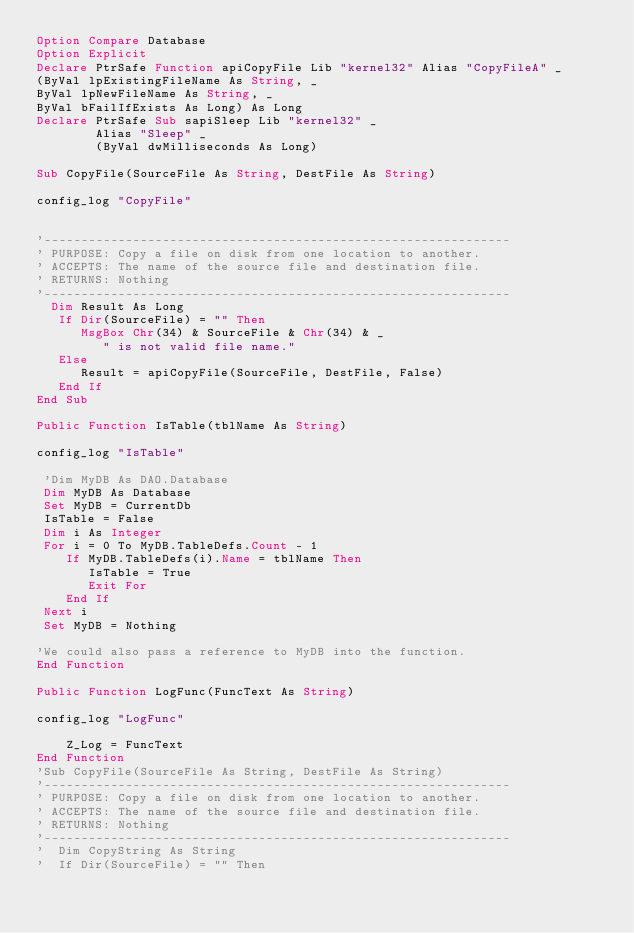Convert code to text. <code><loc_0><loc_0><loc_500><loc_500><_VisualBasic_>Option Compare Database
Option Explicit
Declare PtrSafe Function apiCopyFile Lib "kernel32" Alias "CopyFileA" _
(ByVal lpExistingFileName As String, _
ByVal lpNewFileName As String, _
ByVal bFailIfExists As Long) As Long
Declare PtrSafe Sub sapiSleep Lib "kernel32" _
        Alias "Sleep" _
        (ByVal dwMilliseconds As Long)

Sub CopyFile(SourceFile As String, DestFile As String)

config_log "CopyFile"


'---------------------------------------------------------------
' PURPOSE: Copy a file on disk from one location to another.
' ACCEPTS: The name of the source file and destination file.
' RETURNS: Nothing
'---------------------------------------------------------------
  Dim Result As Long
   If Dir(SourceFile) = "" Then
      MsgBox Chr(34) & SourceFile & Chr(34) & _
         " is not valid file name."
   Else
      Result = apiCopyFile(SourceFile, DestFile, False)
   End If
End Sub

Public Function IsTable(tblName As String)

config_log "IsTable"

 'Dim MyDB As DAO.Database
 Dim MyDB As Database
 Set MyDB = CurrentDb
 IsTable = False
 Dim i As Integer
 For i = 0 To MyDB.TableDefs.Count - 1
    If MyDB.TableDefs(i).Name = tblName Then
       IsTable = True
       Exit For
    End If
 Next i
 Set MyDB = Nothing
 
'We could also pass a reference to MyDB into the function.
End Function

Public Function LogFunc(FuncText As String)

config_log "LogFunc"

    Z_Log = FuncText
End Function
'Sub CopyFile(SourceFile As String, DestFile As String)
'---------------------------------------------------------------
' PURPOSE: Copy a file on disk from one location to another.
' ACCEPTS: The name of the source file and destination file.
' RETURNS: Nothing
'---------------------------------------------------------------
'  Dim CopyString As String
'  If Dir(SourceFile) = "" Then</code> 